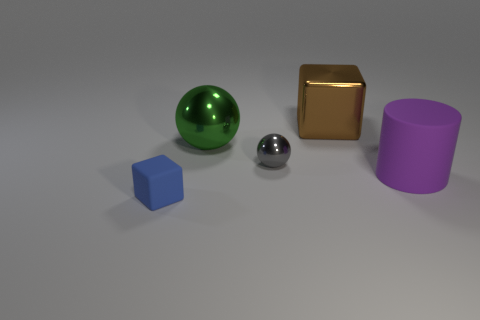Are there an equal number of spheres to the right of the green metal ball and blue matte objects in front of the tiny blue object?
Your answer should be very brief. No. Is there a brown cylinder?
Offer a terse response. No. There is a rubber object that is behind the tiny thing in front of the rubber object to the right of the tiny gray thing; what size is it?
Your answer should be compact. Large. What is the shape of the green metal thing that is the same size as the purple rubber thing?
Provide a short and direct response. Sphere. What number of things are either blocks to the left of the tiny gray thing or big things?
Provide a succinct answer. 4. Is there a big thing that is to the right of the gray ball that is left of the large object that is in front of the big ball?
Provide a succinct answer. Yes. What number of brown things are there?
Ensure brevity in your answer.  1. How many things are balls in front of the green ball or big objects on the right side of the large ball?
Your answer should be very brief. 3. There is a rubber thing on the left side of the gray shiny sphere; is it the same size as the gray metallic thing?
Your response must be concise. Yes. The green thing that is the same shape as the tiny gray thing is what size?
Provide a succinct answer. Large. 